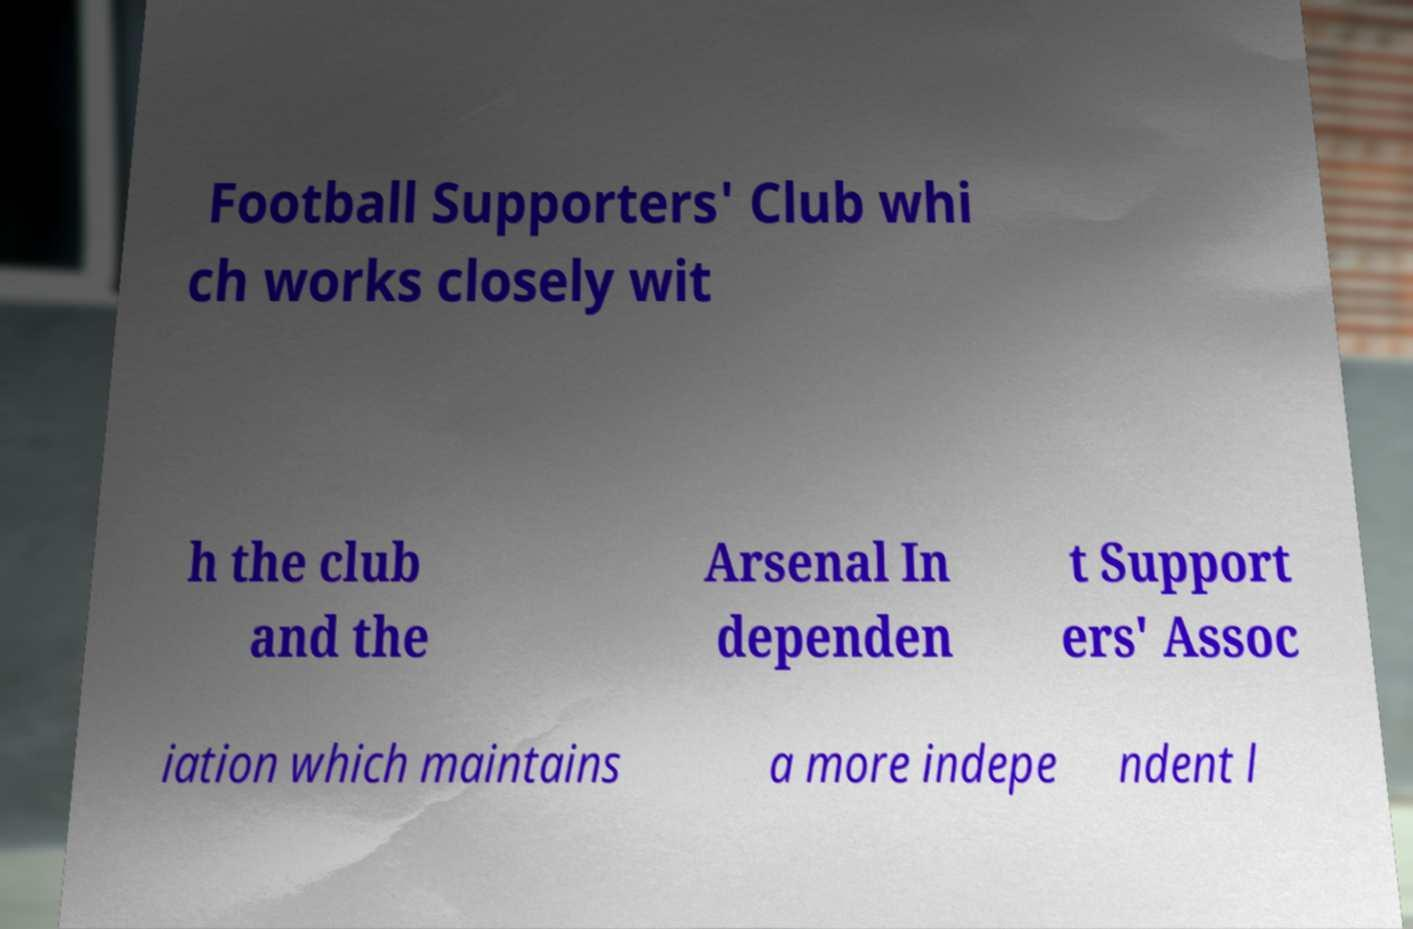Can you read and provide the text displayed in the image?This photo seems to have some interesting text. Can you extract and type it out for me? Football Supporters' Club whi ch works closely wit h the club and the Arsenal In dependen t Support ers' Assoc iation which maintains a more indepe ndent l 